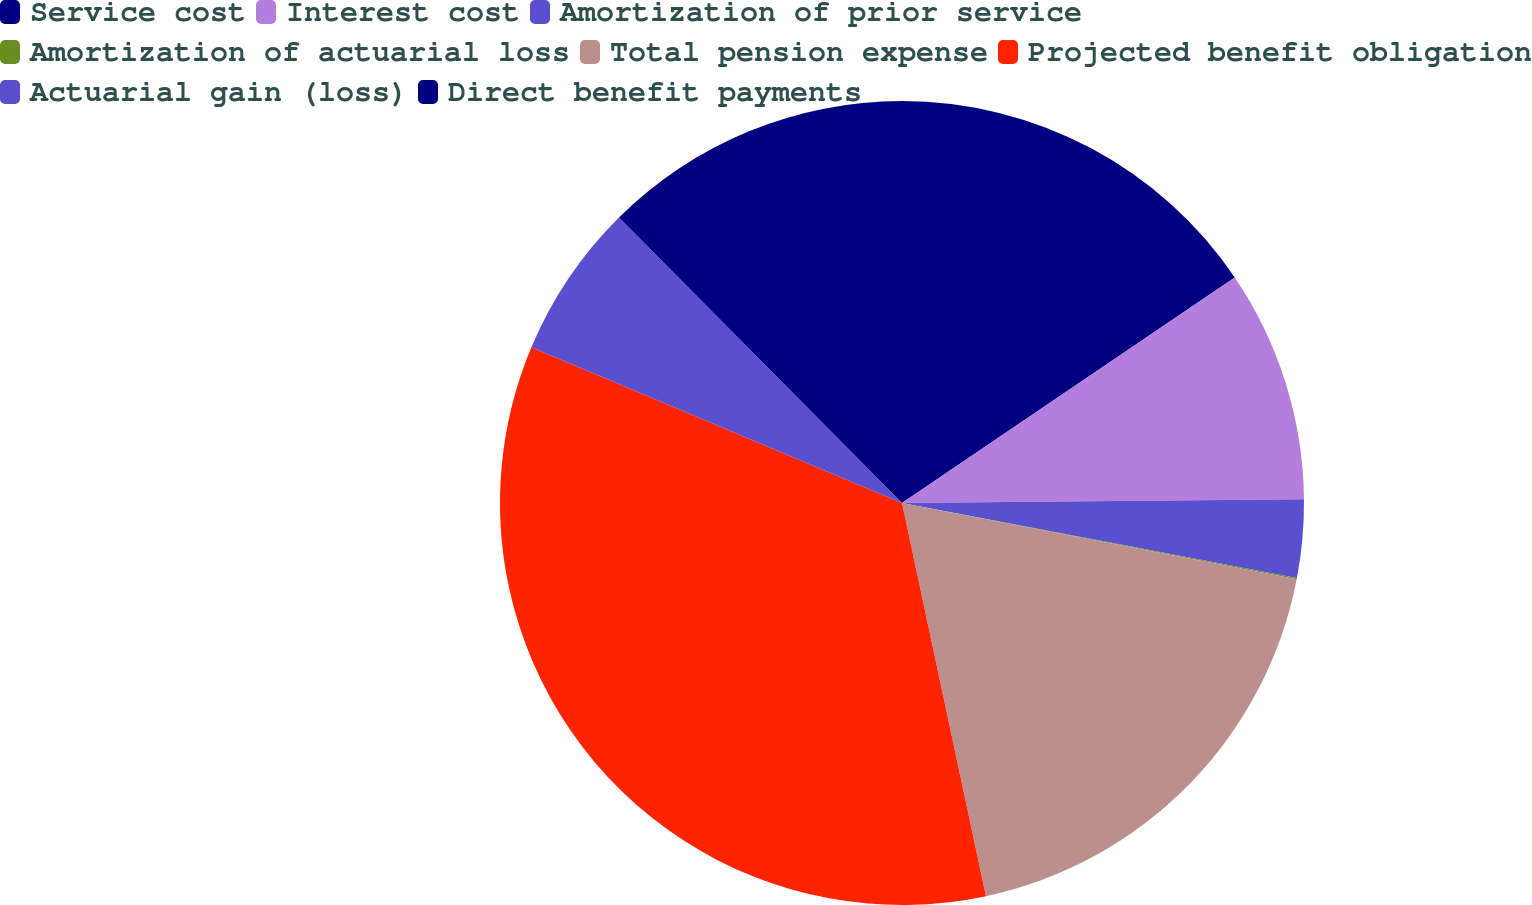Convert chart to OTSL. <chart><loc_0><loc_0><loc_500><loc_500><pie_chart><fcel>Service cost<fcel>Interest cost<fcel>Amortization of prior service<fcel>Amortization of actuarial loss<fcel>Total pension expense<fcel>Projected benefit obligation<fcel>Actuarial gain (loss)<fcel>Direct benefit payments<nl><fcel>15.52%<fcel>9.33%<fcel>3.14%<fcel>0.05%<fcel>18.61%<fcel>34.68%<fcel>6.24%<fcel>12.43%<nl></chart> 